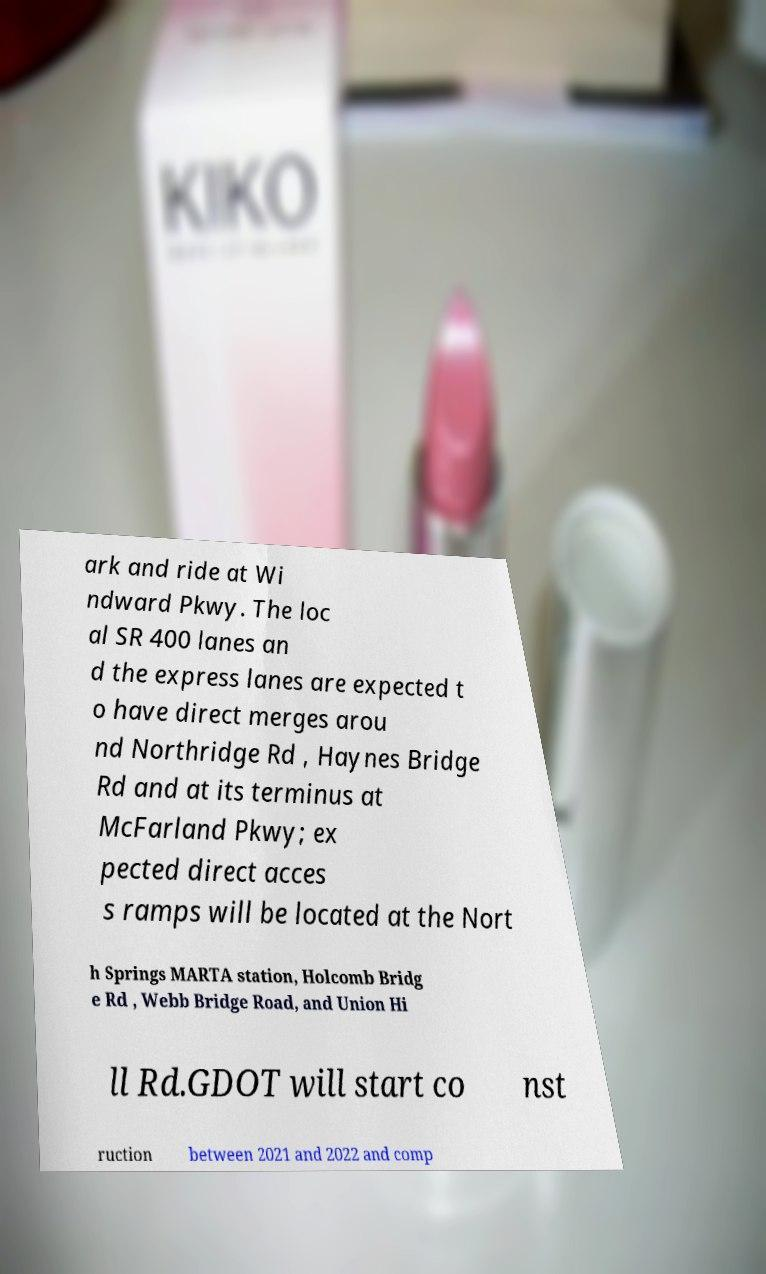Can you accurately transcribe the text from the provided image for me? ark and ride at Wi ndward Pkwy. The loc al SR 400 lanes an d the express lanes are expected t o have direct merges arou nd Northridge Rd , Haynes Bridge Rd and at its terminus at McFarland Pkwy; ex pected direct acces s ramps will be located at the Nort h Springs MARTA station, Holcomb Bridg e Rd , Webb Bridge Road, and Union Hi ll Rd.GDOT will start co nst ruction between 2021 and 2022 and comp 